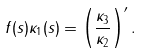Convert formula to latex. <formula><loc_0><loc_0><loc_500><loc_500>f ( s ) \kappa _ { 1 } ( s ) = \left ( \frac { \kappa _ { 3 } } { \kappa _ { 2 } } \right ) ^ { \prime } .</formula> 